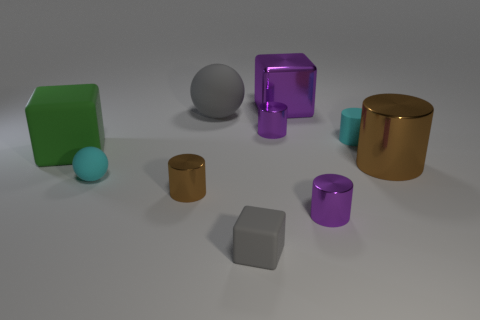Is there a metallic cylinder to the right of the small purple metallic cylinder in front of the block that is left of the small matte cube?
Provide a short and direct response. Yes. Is the color of the tiny rubber block the same as the large sphere that is behind the tiny gray object?
Your answer should be very brief. Yes. What material is the brown cylinder on the right side of the small purple metal cylinder in front of the brown thing behind the small brown object?
Offer a terse response. Metal. What shape is the purple metallic object in front of the big green cube?
Your answer should be very brief. Cylinder. The brown thing that is the same material as the big cylinder is what size?
Provide a short and direct response. Small. What number of big gray matte things are the same shape as the large brown metal object?
Provide a succinct answer. 0. Does the sphere in front of the cyan matte cylinder have the same color as the rubber cylinder?
Your answer should be very brief. Yes. What number of cylinders are behind the large thing that is to the right of the small cyan thing that is behind the large green thing?
Keep it short and to the point. 2. What number of metal cylinders are both behind the large rubber block and in front of the small brown object?
Offer a terse response. 0. There is a metal object that is the same color as the big metal cylinder; what shape is it?
Give a very brief answer. Cylinder. 